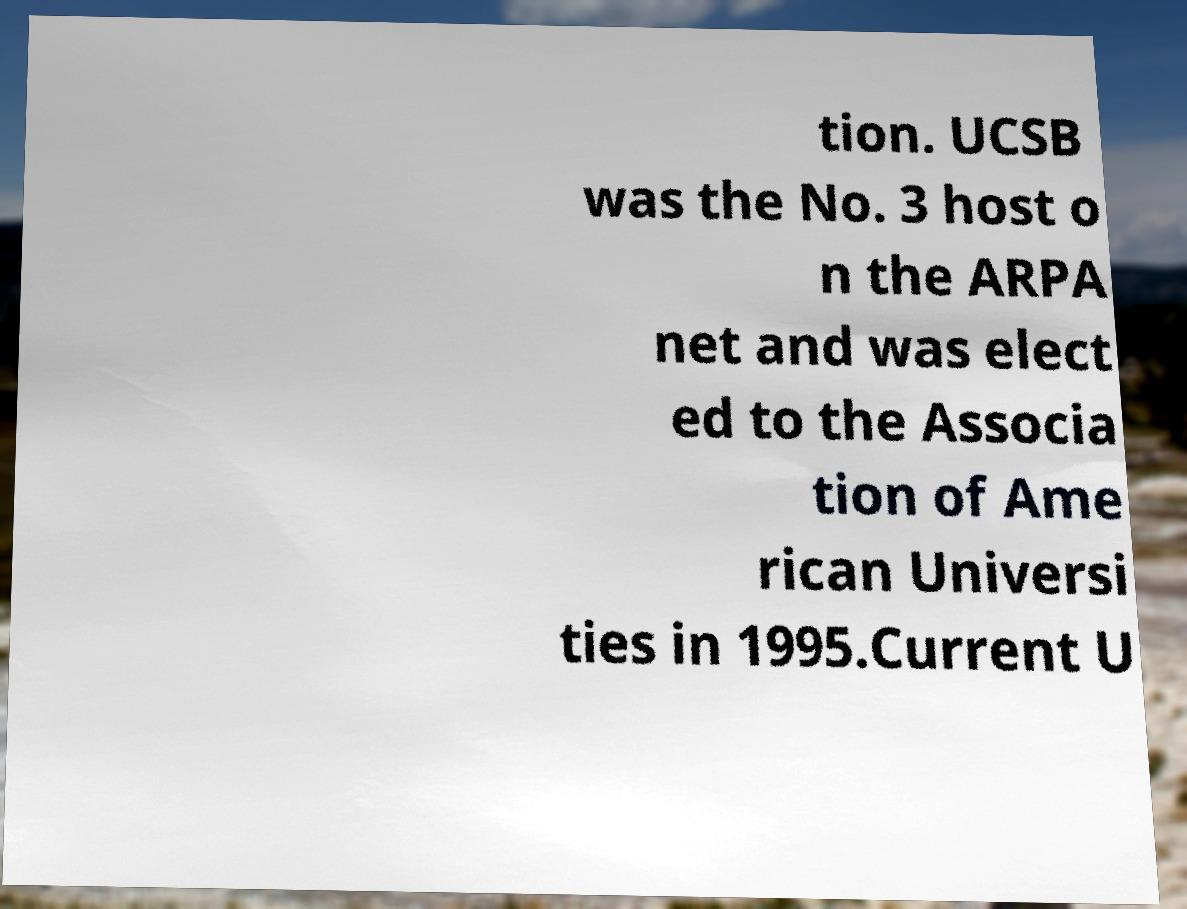Please read and relay the text visible in this image. What does it say? tion. UCSB was the No. 3 host o n the ARPA net and was elect ed to the Associa tion of Ame rican Universi ties in 1995.Current U 